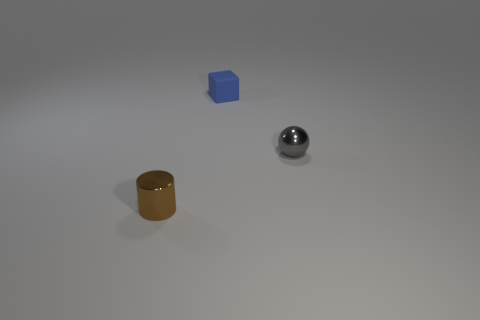Is there any other thing that has the same material as the tiny blue cube?
Your answer should be compact. No. Is there a small red metallic object of the same shape as the rubber thing?
Provide a short and direct response. No. There is a thing that is behind the tiny shiny object that is to the right of the brown thing; what is its material?
Offer a terse response. Rubber. What size is the rubber block?
Your answer should be compact. Small. What shape is the shiny object behind the small thing in front of the metal object right of the brown thing?
Your answer should be compact. Sphere. What number of things are gray balls or metallic objects that are to the right of the brown cylinder?
Ensure brevity in your answer.  1. There is a shiny thing that is in front of the small sphere; what is its size?
Make the answer very short. Small. Do the brown thing and the thing to the right of the tiny cube have the same material?
Ensure brevity in your answer.  Yes. There is a metallic object that is to the right of the shiny object on the left side of the cube; what number of small shiny cylinders are in front of it?
Your response must be concise. 1. How many gray objects are tiny metal spheres or matte objects?
Offer a terse response. 1. 